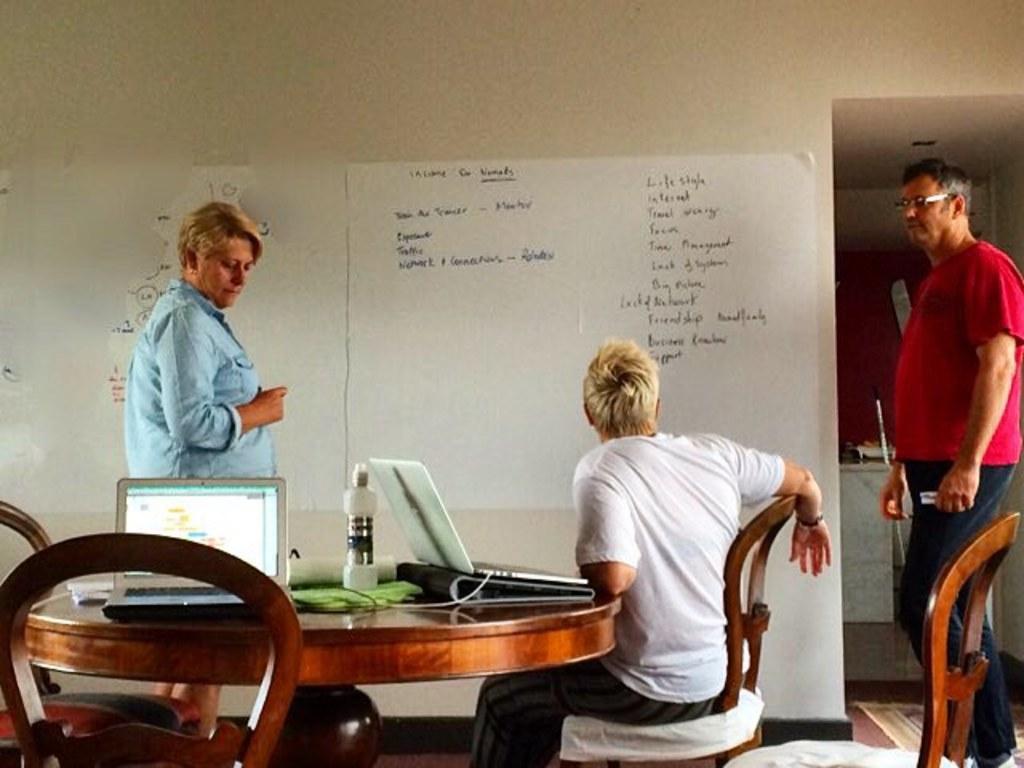How would you summarize this image in a sentence or two? In this image I can see three people. Among them one person is sitting in front of the table. On the table there are two laptops and a bottle. To the wall there is a board. 